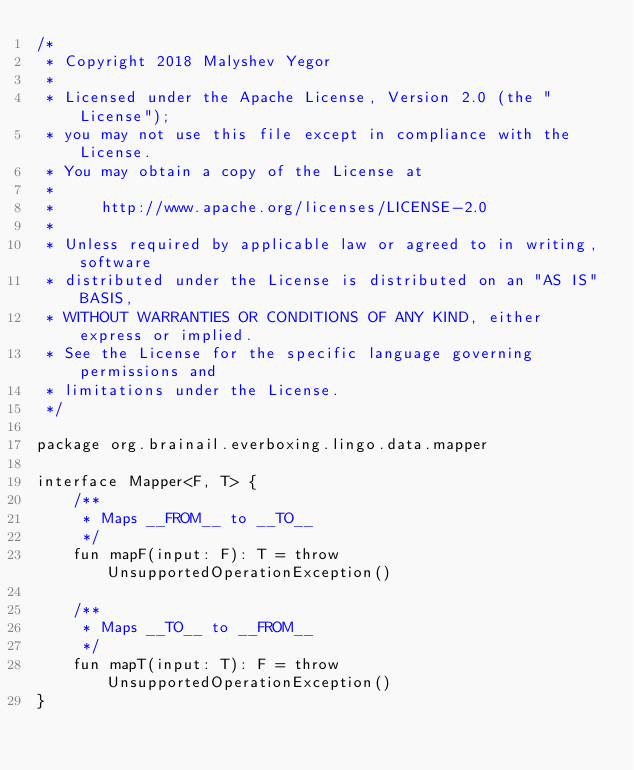Convert code to text. <code><loc_0><loc_0><loc_500><loc_500><_Kotlin_>/*
 * Copyright 2018 Malyshev Yegor
 *
 * Licensed under the Apache License, Version 2.0 (the "License");
 * you may not use this file except in compliance with the License.
 * You may obtain a copy of the License at
 *
 *     http://www.apache.org/licenses/LICENSE-2.0
 *
 * Unless required by applicable law or agreed to in writing, software
 * distributed under the License is distributed on an "AS IS" BASIS,
 * WITHOUT WARRANTIES OR CONDITIONS OF ANY KIND, either express or implied.
 * See the License for the specific language governing permissions and
 * limitations under the License.
 */

package org.brainail.everboxing.lingo.data.mapper

interface Mapper<F, T> {
    /**
     * Maps __FROM__ to __TO__
     */
    fun mapF(input: F): T = throw UnsupportedOperationException()

    /**
     * Maps __TO__ to __FROM__
     */
    fun mapT(input: T): F = throw UnsupportedOperationException()
}
</code> 